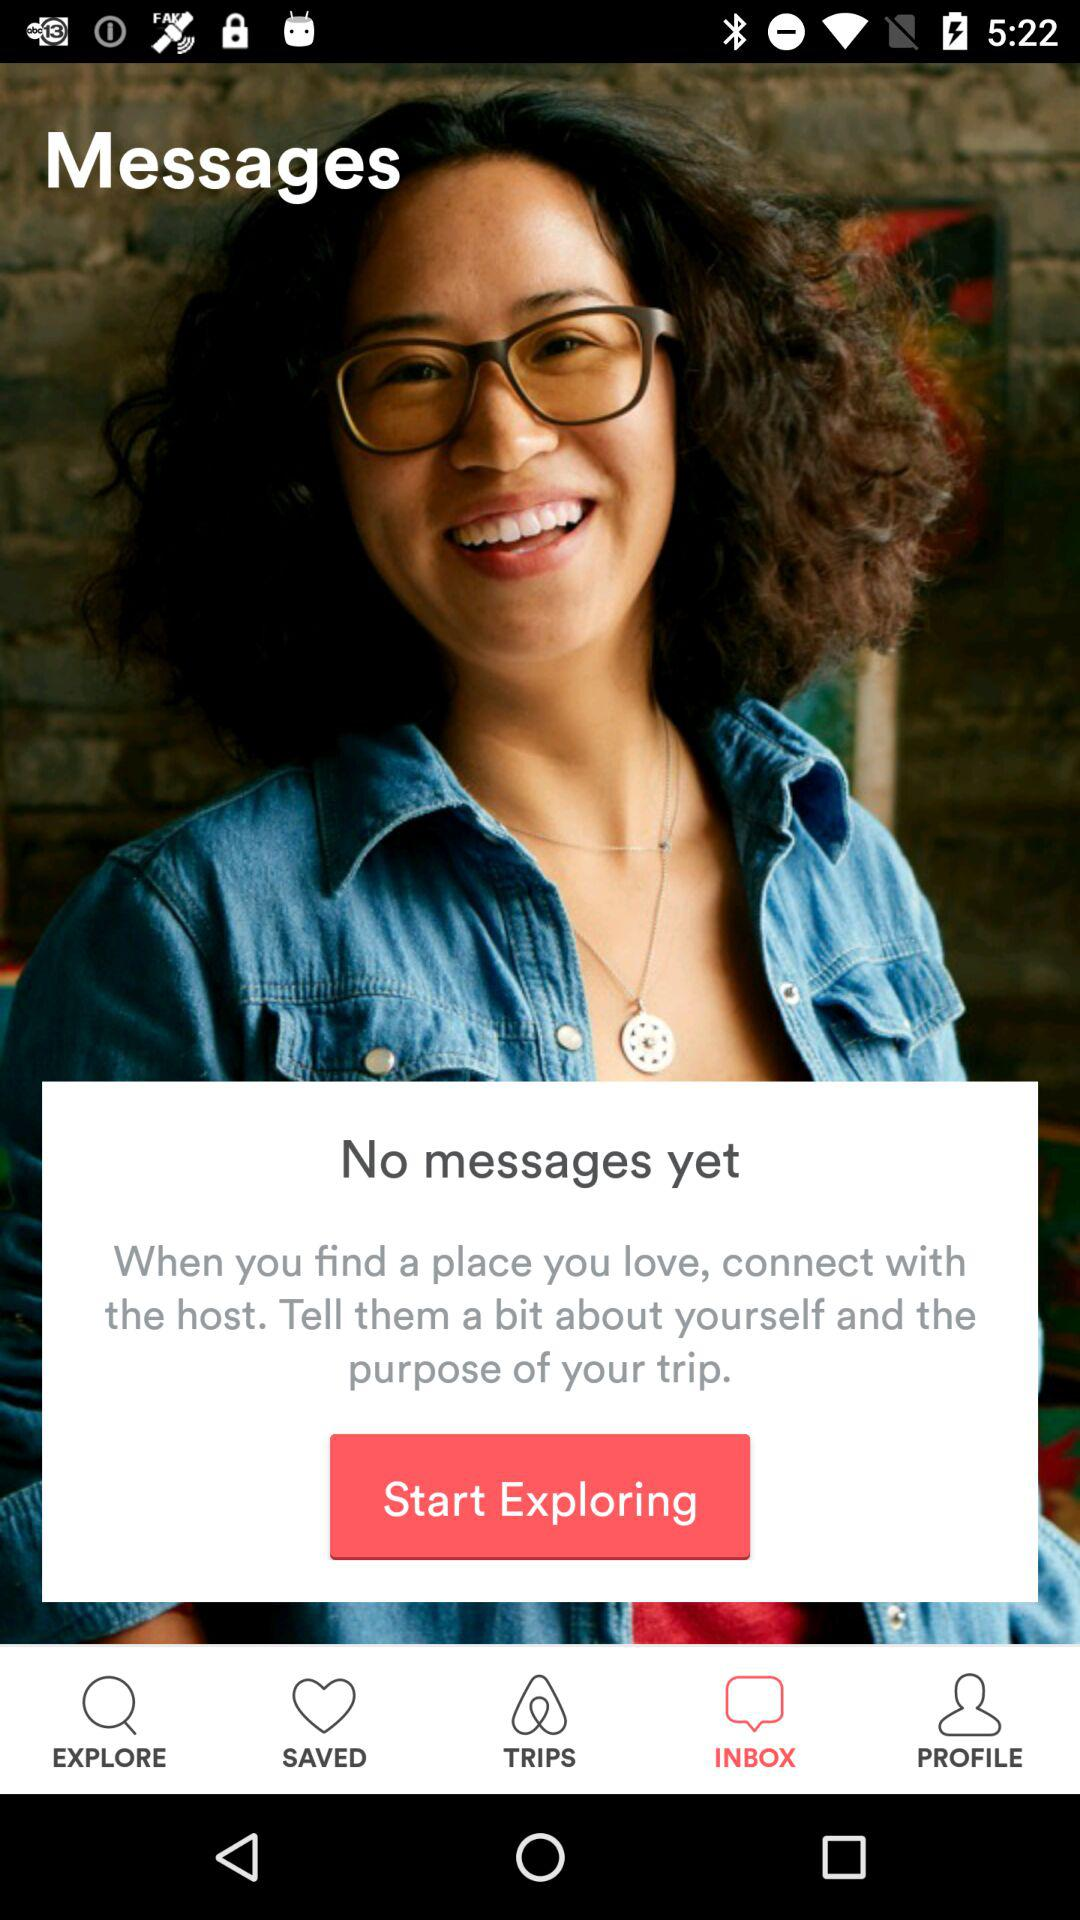Is there any message? There is no message. 